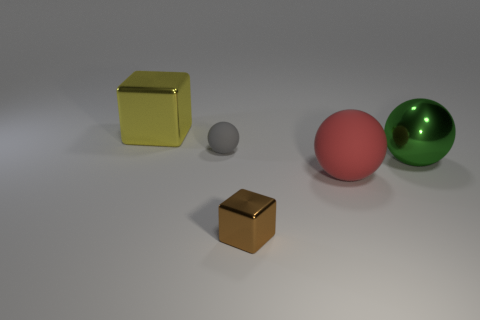How many rubber objects are tiny green balls or green things?
Keep it short and to the point. 0. Are there any other objects that have the same material as the small brown object?
Provide a short and direct response. Yes. How many objects are either cubes in front of the large yellow shiny thing or tiny things that are in front of the large green thing?
Your response must be concise. 1. Do the matte thing that is on the right side of the small brown metal cube and the big block have the same color?
Make the answer very short. No. What material is the tiny gray ball?
Give a very brief answer. Rubber. Is the size of the shiny object that is in front of the red sphere the same as the red sphere?
Provide a succinct answer. No. Is there any other thing that is the same size as the red rubber object?
Offer a terse response. Yes. What is the size of the other metal thing that is the same shape as the yellow thing?
Your answer should be compact. Small. Are there the same number of big metal cubes right of the large rubber sphere and big red balls that are behind the big yellow metallic thing?
Your answer should be compact. Yes. What is the size of the matte thing in front of the green shiny sphere?
Ensure brevity in your answer.  Large. 